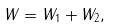<formula> <loc_0><loc_0><loc_500><loc_500>W = W _ { 1 } + W _ { 2 } ,</formula> 